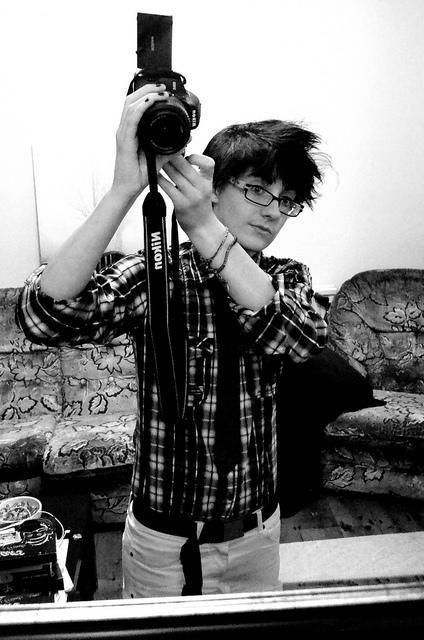How many couches can be seen?
Give a very brief answer. 2. 